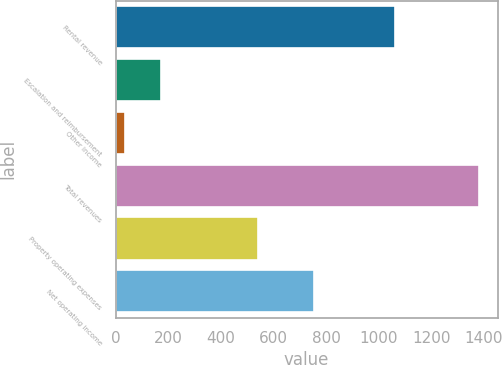<chart> <loc_0><loc_0><loc_500><loc_500><bar_chart><fcel>Rental revenue<fcel>Escalation and reimbursement<fcel>Other income<fcel>Total revenues<fcel>Property operating expenses<fcel>Net operating income<nl><fcel>1062.7<fcel>170.4<fcel>35.7<fcel>1382.7<fcel>539.6<fcel>754.1<nl></chart> 